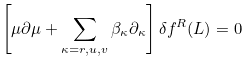<formula> <loc_0><loc_0><loc_500><loc_500>\left [ \mu \partial \mu + \sum _ { \kappa = r , u , v } \beta _ { \kappa } \partial _ { \kappa } \right ] \delta f ^ { R } ( L ) = 0</formula> 